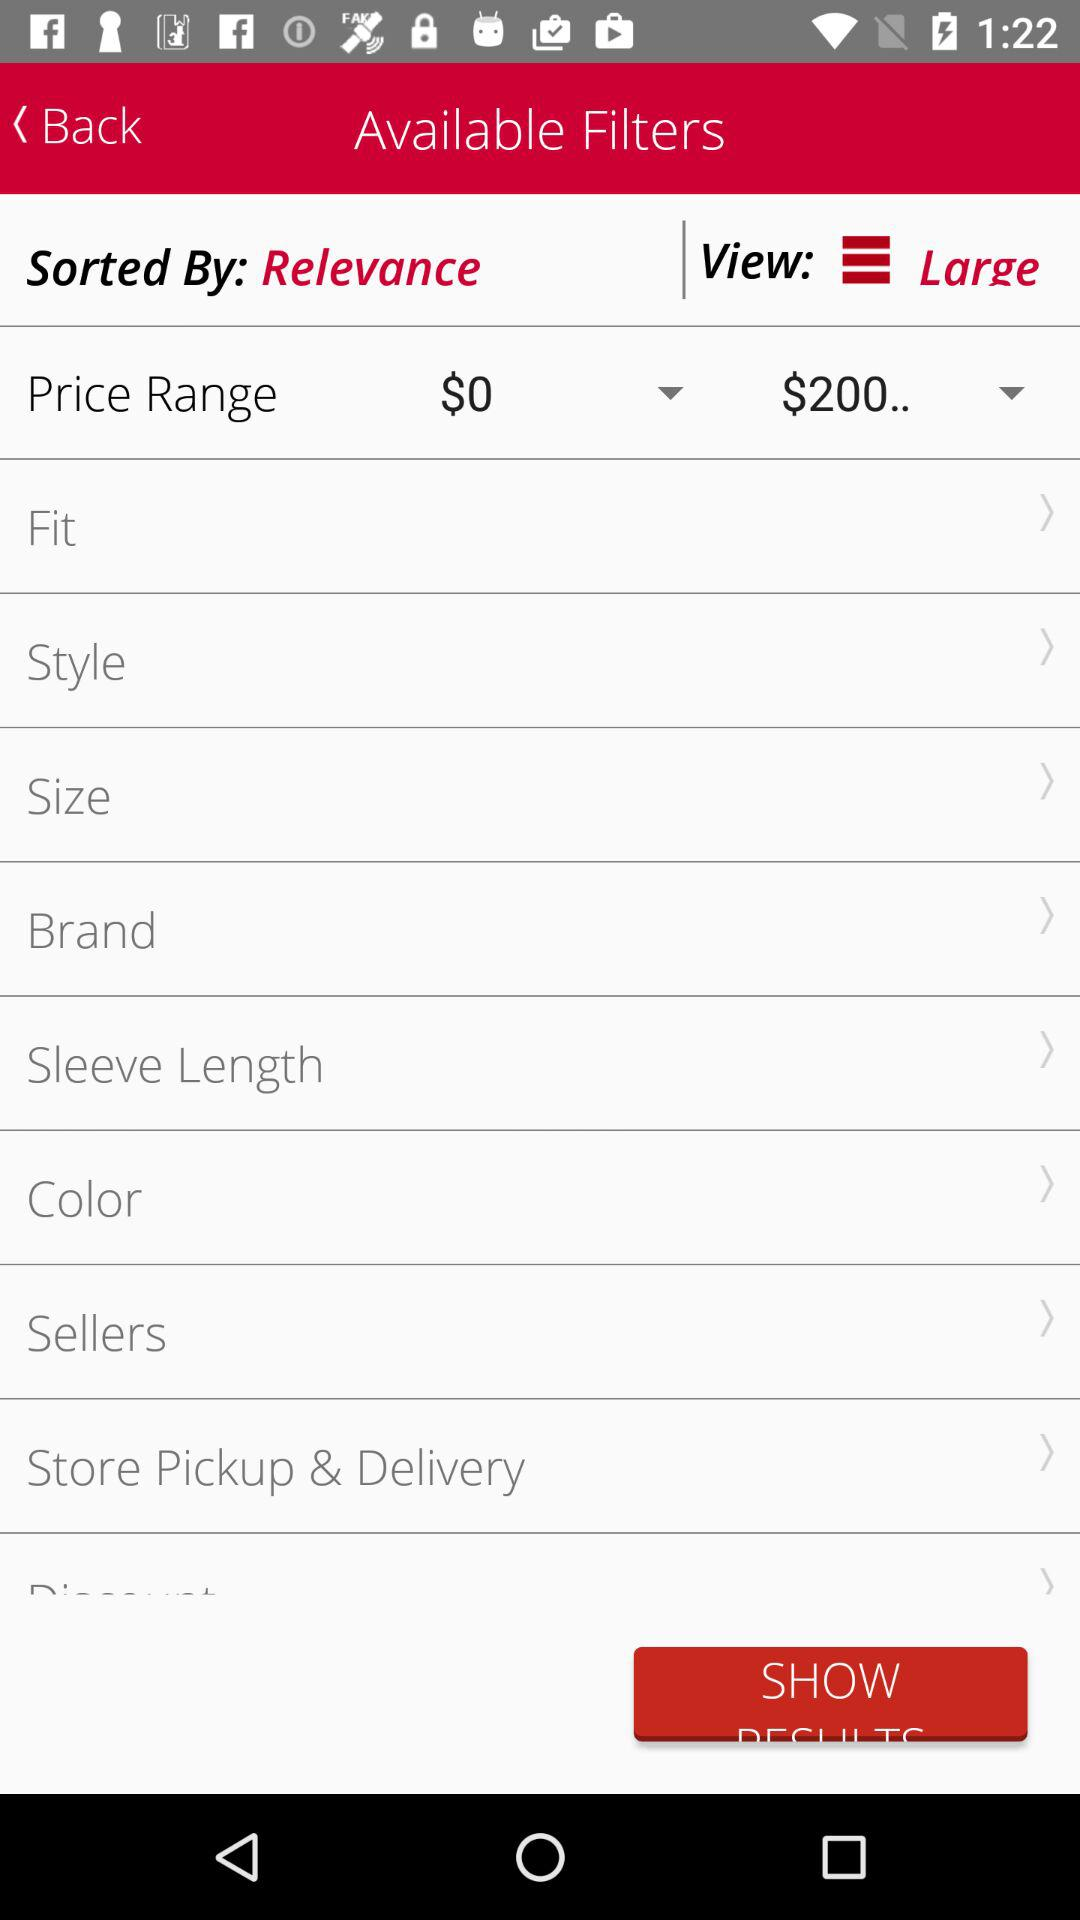What is the sorted order of the list? The sorted order of the list is "Relevance". 